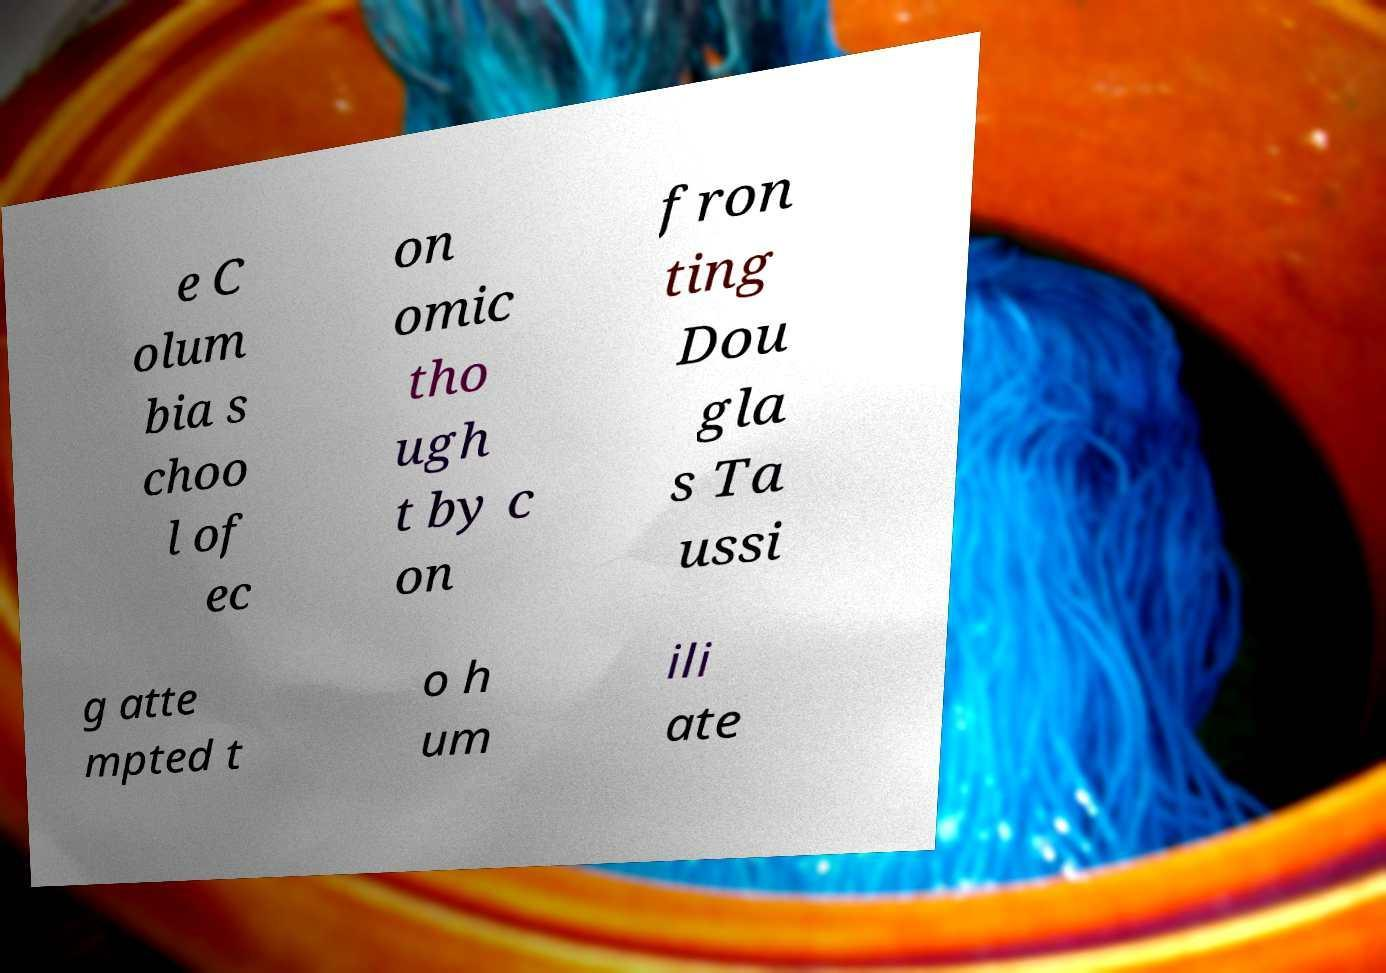Can you read and provide the text displayed in the image?This photo seems to have some interesting text. Can you extract and type it out for me? e C olum bia s choo l of ec on omic tho ugh t by c on fron ting Dou gla s Ta ussi g atte mpted t o h um ili ate 